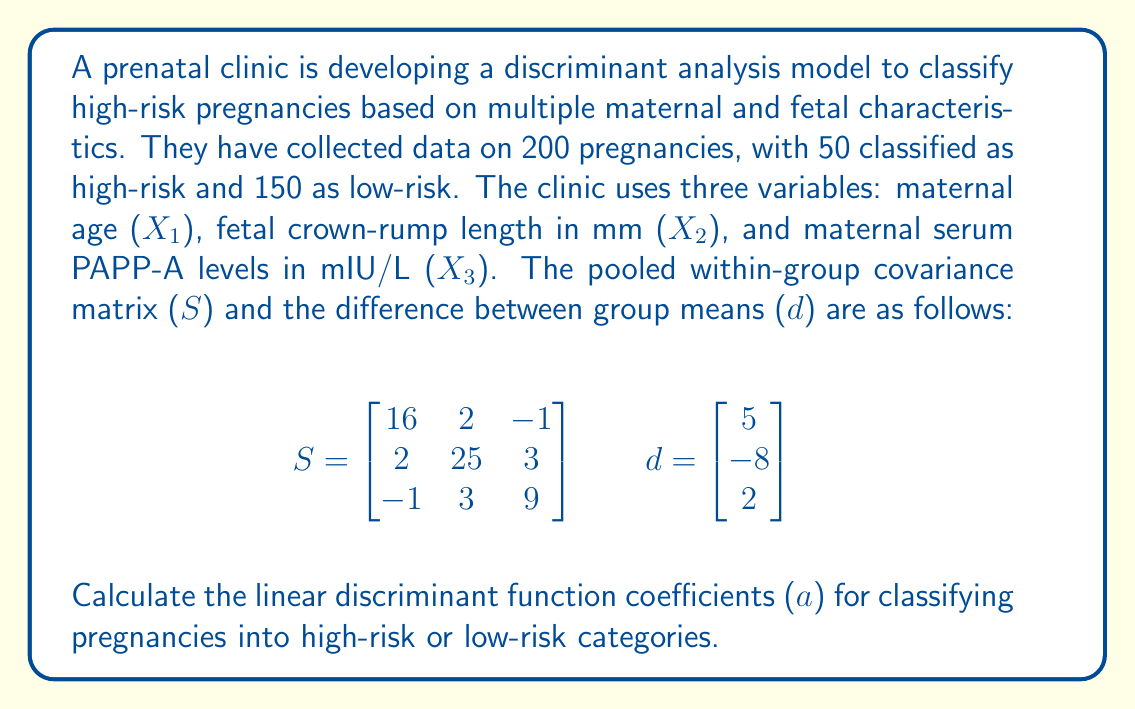What is the answer to this math problem? To solve this problem, we need to use the linear discriminant analysis (LDA) formula:

$$a = S^{-1}d$$

Where:
- $a$ is the vector of linear discriminant function coefficients
- $S^{-1}$ is the inverse of the pooled within-group covariance matrix
- $d$ is the difference between group means

Steps to solve:

1. First, we need to find the inverse of the covariance matrix $S$. We can use the matrix inverse formula or a calculator for this step. The result is:

$$S^{-1} = \begin{bmatrix}
0.0650 & -0.0052 & 0.0075 \\
-0.0052 & 0.0421 & -0.0137 \\
0.0075 & -0.0137 & 0.1147
\end{bmatrix}$$

2. Now, we multiply $S^{-1}$ by $d$:

$$a = S^{-1}d = \begin{bmatrix}
0.0650 & -0.0052 & 0.0075 \\
-0.0052 & 0.0421 & -0.0137 \\
0.0075 & -0.0137 & 0.1147
\end{bmatrix} \times \begin{bmatrix}
5 \\
-8 \\
2
\end{bmatrix}$$

3. Performing the matrix multiplication:

$$a = \begin{bmatrix}
(0.0650 \times 5) + (-0.0052 \times -8) + (0.0075 \times 2) \\
(-0.0052 \times 5) + (0.0421 \times -8) + (-0.0137 \times 2) \\
(0.0075 \times 5) + (-0.0137 \times -8) + (0.1147 \times 2)
\end{bmatrix}$$

4. Calculating the final values:

$$a = \begin{bmatrix}
0.3250 + 0.0416 + 0.0150 \\
-0.0260 - 0.3368 - 0.0274 \\
0.0375 + 0.1096 + 0.2294
\end{bmatrix} = \begin{bmatrix}
0.3816 \\
-0.3902 \\
0.3765
\end{bmatrix}$$
Answer: The linear discriminant function coefficients (a) for classifying pregnancies into high-risk or low-risk categories are:

$$a = \begin{bmatrix}
0.3816 \\
-0.3902 \\
0.3765
\end{bmatrix}$$ 